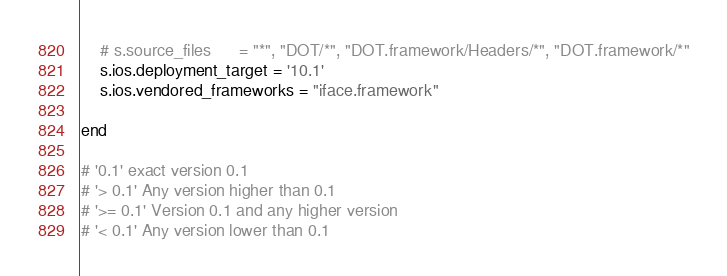<code> <loc_0><loc_0><loc_500><loc_500><_Ruby_>    # s.source_files      = "*", "DOT/*", "DOT.framework/Headers/*", "DOT.framework/*"
    s.ios.deployment_target = '10.1'
    s.ios.vendored_frameworks = "iface.framework"

end

# '0.1' exact version 0.1
# '> 0.1' Any version higher than 0.1
# '>= 0.1' Version 0.1 and any higher version
# '< 0.1' Any version lower than 0.1</code> 